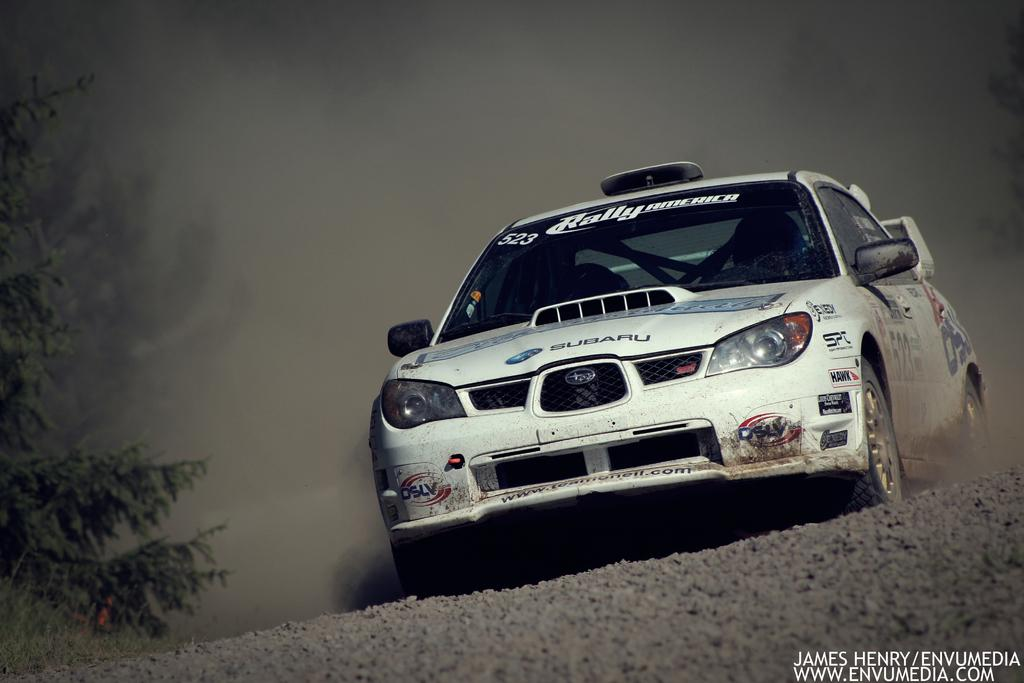What is the main subject of the image? There is a car in the image. Where is the car located? The car is on the road. What can be seen on the left side of the image? There are trees on the left side of the image. What type of steam is coming out of the car's exhaust in the image? There is no steam coming out of the car's exhaust in the image. How many roses can be seen growing near the car in the image? There are no roses present in the image. 